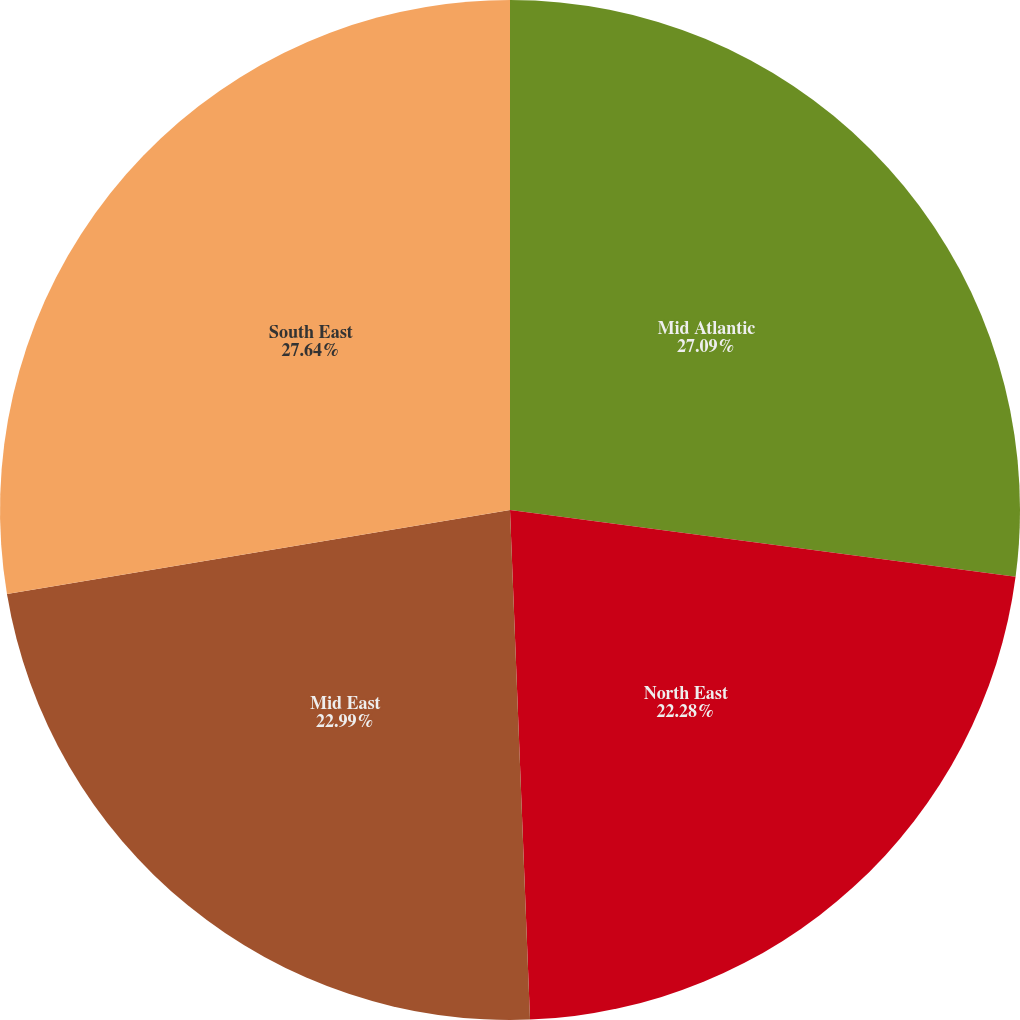Convert chart to OTSL. <chart><loc_0><loc_0><loc_500><loc_500><pie_chart><fcel>Mid Atlantic<fcel>North East<fcel>Mid East<fcel>South East<nl><fcel>27.09%<fcel>22.28%<fcel>22.99%<fcel>27.63%<nl></chart> 